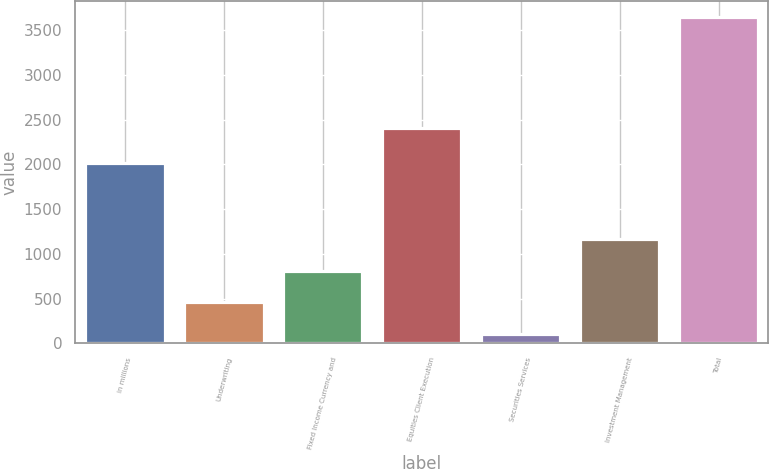Convert chart. <chart><loc_0><loc_0><loc_500><loc_500><bar_chart><fcel>in millions<fcel>Underwriting<fcel>Fixed Income Currency and<fcel>Equities Client Execution<fcel>Securities Services<fcel>Investment Management<fcel>Total<nl><fcel>2014<fcel>459<fcel>813<fcel>2403<fcel>105<fcel>1167<fcel>3645<nl></chart> 